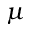Convert formula to latex. <formula><loc_0><loc_0><loc_500><loc_500>\mu</formula> 